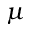Convert formula to latex. <formula><loc_0><loc_0><loc_500><loc_500>\mu</formula> 